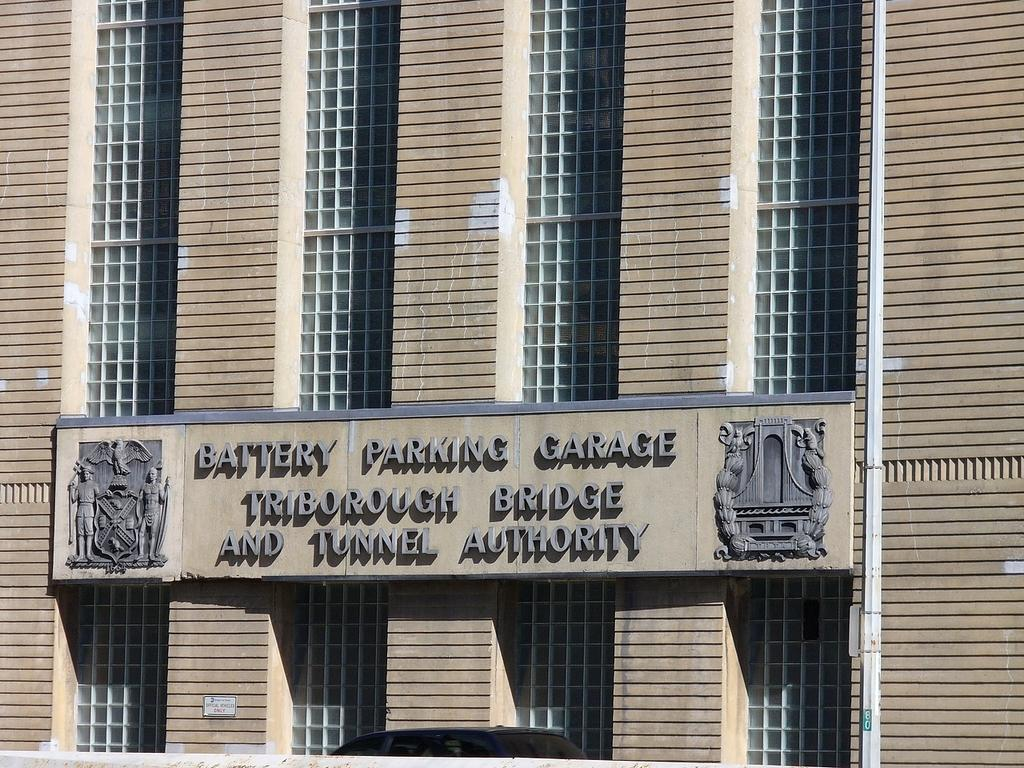What is the main subject of the image? The main subject of the image is a building. Can you describe any specific features of the building? Yes, there is a name board on the building. What type of copper material is used to make the scarecrow in the image? There is no scarecrow or copper material present in the image. 